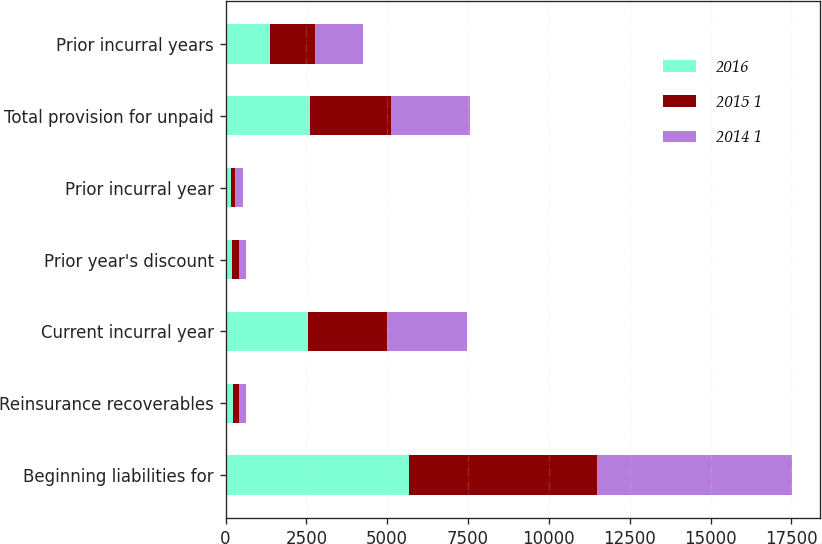Convert chart to OTSL. <chart><loc_0><loc_0><loc_500><loc_500><stacked_bar_chart><ecel><fcel>Beginning liabilities for<fcel>Reinsurance recoverables<fcel>Current incurral year<fcel>Prior year's discount<fcel>Prior incurral year<fcel>Total provision for unpaid<fcel>Prior incurral years<nl><fcel>2016<fcel>5671<fcel>218<fcel>2562<fcel>202<fcel>162<fcel>2602<fcel>1382<nl><fcel>2015 1<fcel>5804<fcel>209<fcel>2447<fcel>214<fcel>146<fcel>2515<fcel>1391<nl><fcel>2014 1<fcel>6048<fcel>210<fcel>2446<fcel>225<fcel>223<fcel>2448<fcel>1482<nl></chart> 